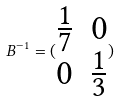<formula> <loc_0><loc_0><loc_500><loc_500>B ^ { - 1 } = ( \begin{matrix} \frac { 1 } { 7 } & 0 \\ 0 & \frac { 1 } { 3 } \\ \end{matrix} )</formula> 